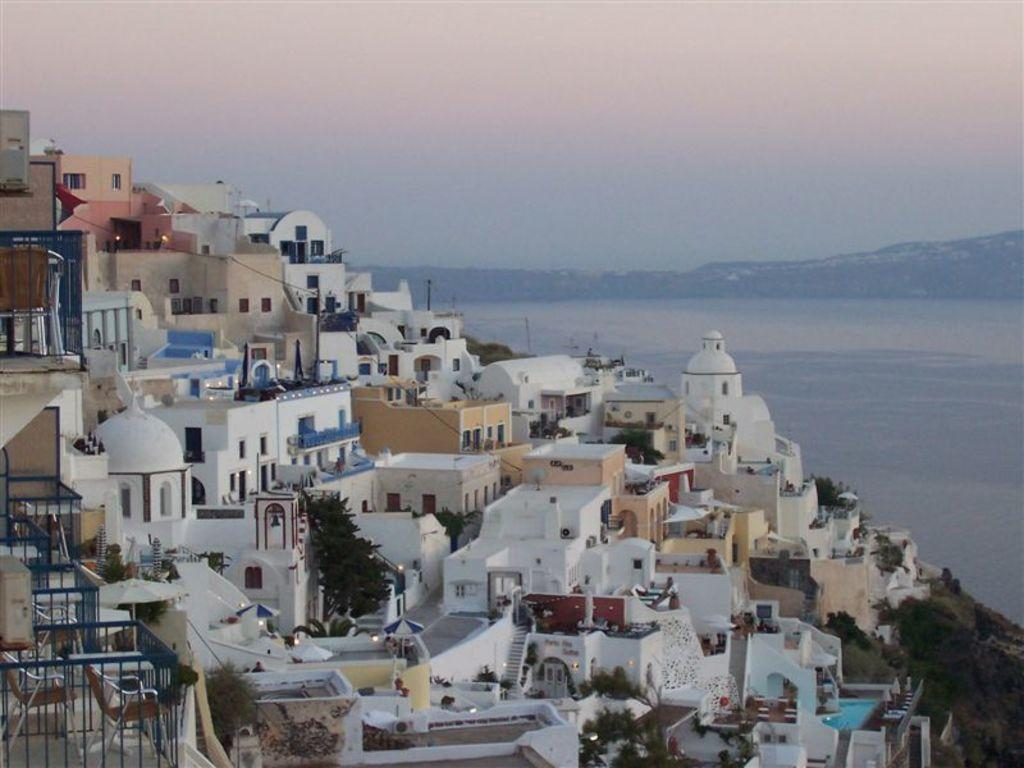What type of structures can be seen in the image? There are buildings in the image. Are there any architectural features visible in the image? Yes, there are stairs in the image. What type of vegetation is present in the image? There are trees and plants in the image. Is there any water visible in the image? Yes, there is water visible in the image. What can be seen in the background of the image? There are trees in the background of the image. What is visible at the top of the image? The sky is visible at the top of the image. What type of shoes can be seen hanging from the trees in the image? There are no shoes hanging from the trees in the image; only trees, plants, and buildings are present. What type of joke is being told by the trees in the image? There are no jokes being told by the trees in the image; they are simply trees and plants. 